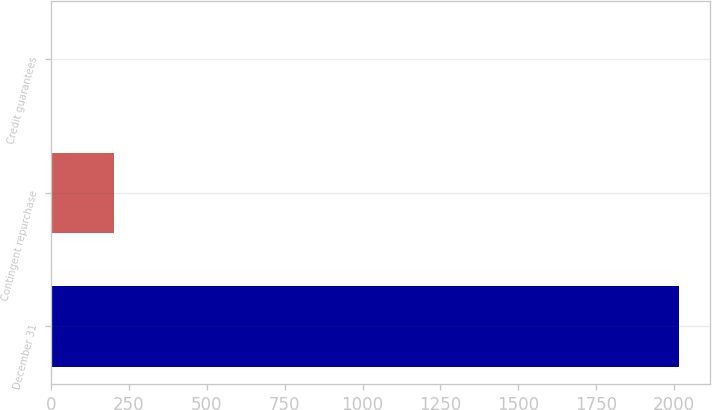Convert chart to OTSL. <chart><loc_0><loc_0><loc_500><loc_500><bar_chart><fcel>December 31<fcel>Contingent repurchase<fcel>Credit guarantees<nl><fcel>2015<fcel>203.3<fcel>2<nl></chart> 